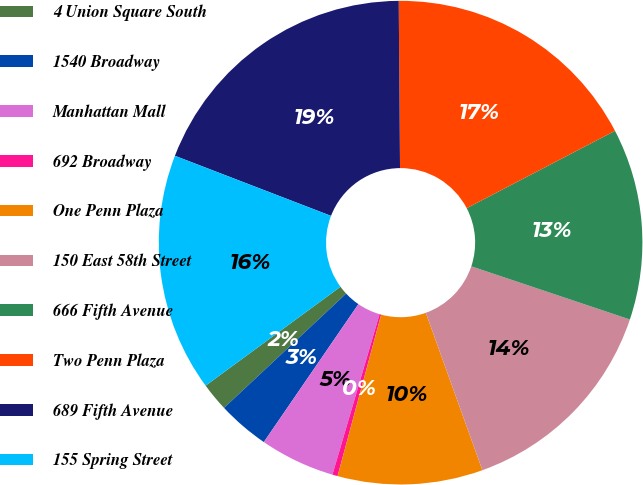<chart> <loc_0><loc_0><loc_500><loc_500><pie_chart><fcel>4 Union Square South<fcel>1540 Broadway<fcel>Manhattan Mall<fcel>692 Broadway<fcel>One Penn Plaza<fcel>150 East 58th Street<fcel>666 Fifth Avenue<fcel>Two Penn Plaza<fcel>689 Fifth Avenue<fcel>155 Spring Street<nl><fcel>1.9%<fcel>3.46%<fcel>5.02%<fcel>0.35%<fcel>9.69%<fcel>14.36%<fcel>12.8%<fcel>17.47%<fcel>19.03%<fcel>15.92%<nl></chart> 